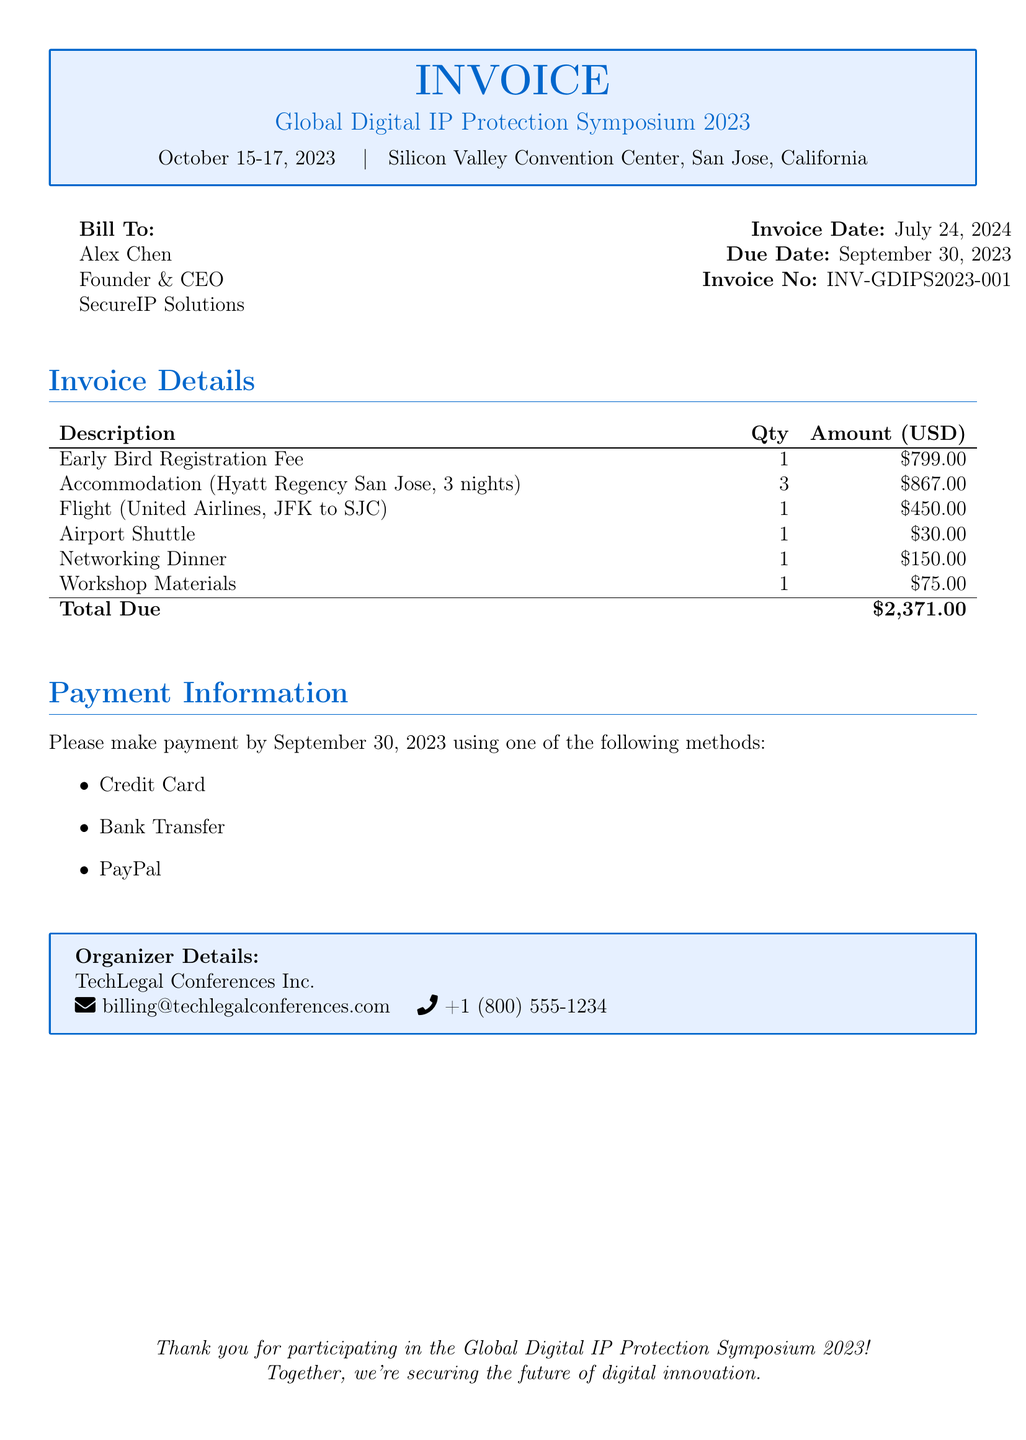What is the due date for the invoice? The due date for the invoice is explicitly stated in the document under the billing information section.
Answer: September 30, 2023 Who is the bill to? The name of the person or organization being billed is indicated at the top of the document under "Bill To."
Answer: Alex Chen What is the total amount due? The total amount due can be found in the invoice details section as the sum of all line items.
Answer: $2,371.00 How many nights of accommodation are included? The number of nights of accommodation is specified in the details of the accommodation line item.
Answer: 3 What is the invoice number? The unique identifier for the invoice is provided in the document, listed next to the invoice date.
Answer: INV-GDIPS2023-001 What is included in the total due? The total due is the sum of all individual amounts listed in the invoice details, indicating the components of the total.
Answer: Early Bird Registration Fee, Accommodation, Flight, Airport Shuttle, Networking Dinner, Workshop Materials Which conference is this invoice for? The specific conference referenced in the document is mentioned prominently in the title box at the beginning.
Answer: Global Digital IP Protection Symposium 2023 What organization is responsible for the symposium? The entity organizing the event is listed at the bottom of the document under organizer details.
Answer: TechLegal Conferences Inc 